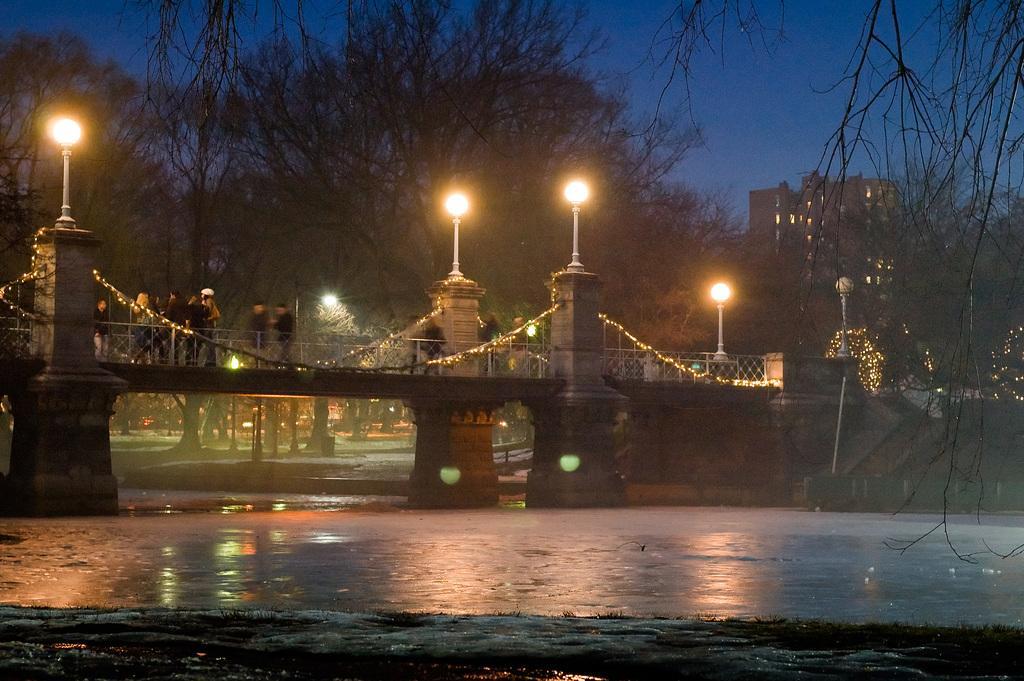How would you summarize this image in a sentence or two? In the image there is a bridge in the back with few people walking on it and street lights on either side of it and below its a lake and behind it there are trees, over the background there is a building and above its sky. 